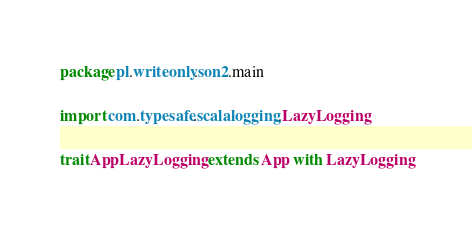Convert code to text. <code><loc_0><loc_0><loc_500><loc_500><_Scala_>package pl.writeonly.son2.main

import com.typesafe.scalalogging.LazyLogging

trait AppLazyLogging extends App with LazyLogging
</code> 